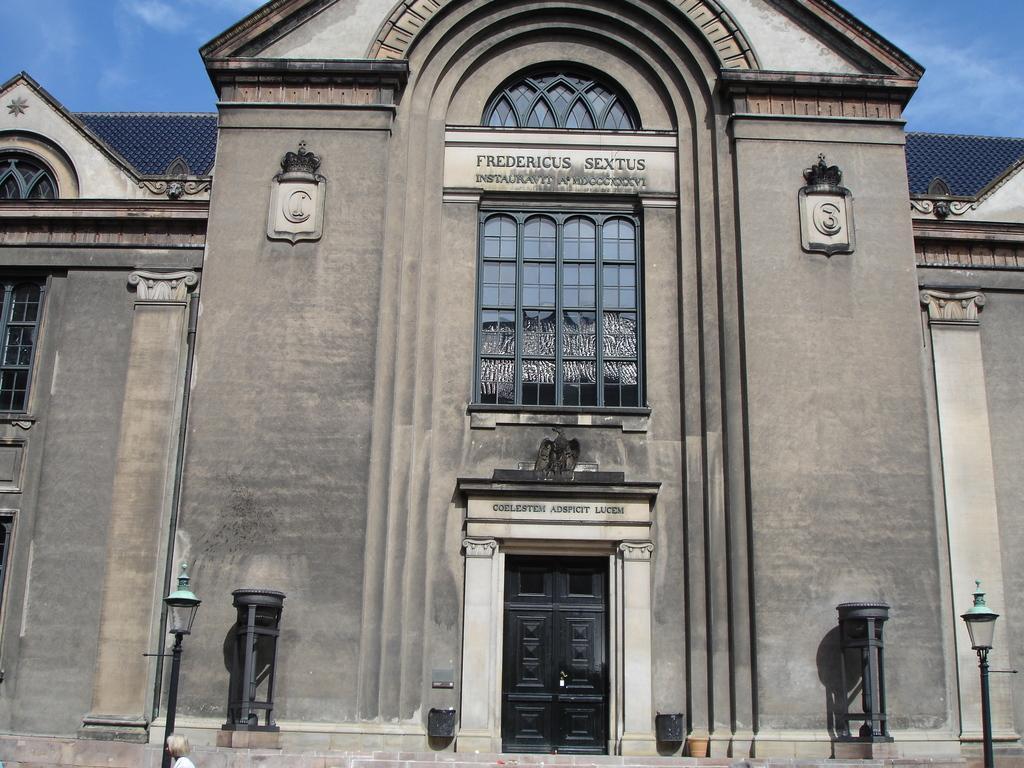In one or two sentences, can you explain what this image depicts? In this picture I can see a building and a couple of pole lights and I can see text on the building and a blue cloudy sky and I can see a door. 